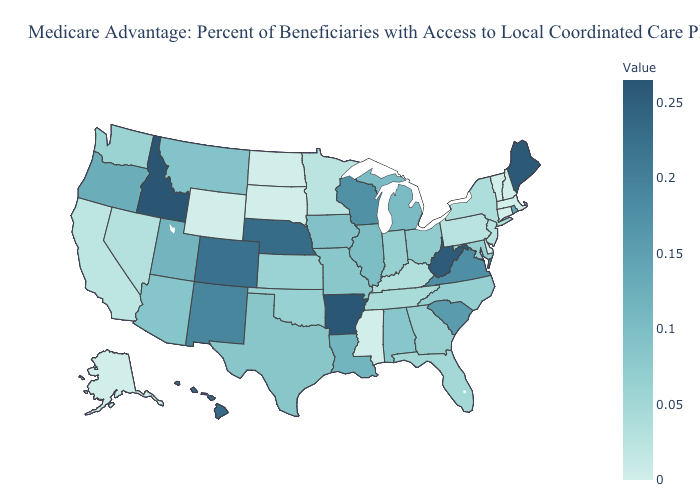Does Maine have the highest value in the Northeast?
Write a very short answer. Yes. Does Oklahoma have the highest value in the USA?
Short answer required. No. Among the states that border Colorado , does Arizona have the highest value?
Write a very short answer. No. Does Oregon have a lower value than North Carolina?
Short answer required. No. Which states have the lowest value in the USA?
Concise answer only. Alaska, Connecticut, Delaware, Massachusetts, Mississippi, North Dakota, New Hampshire, South Dakota, Vermont, Wyoming. 